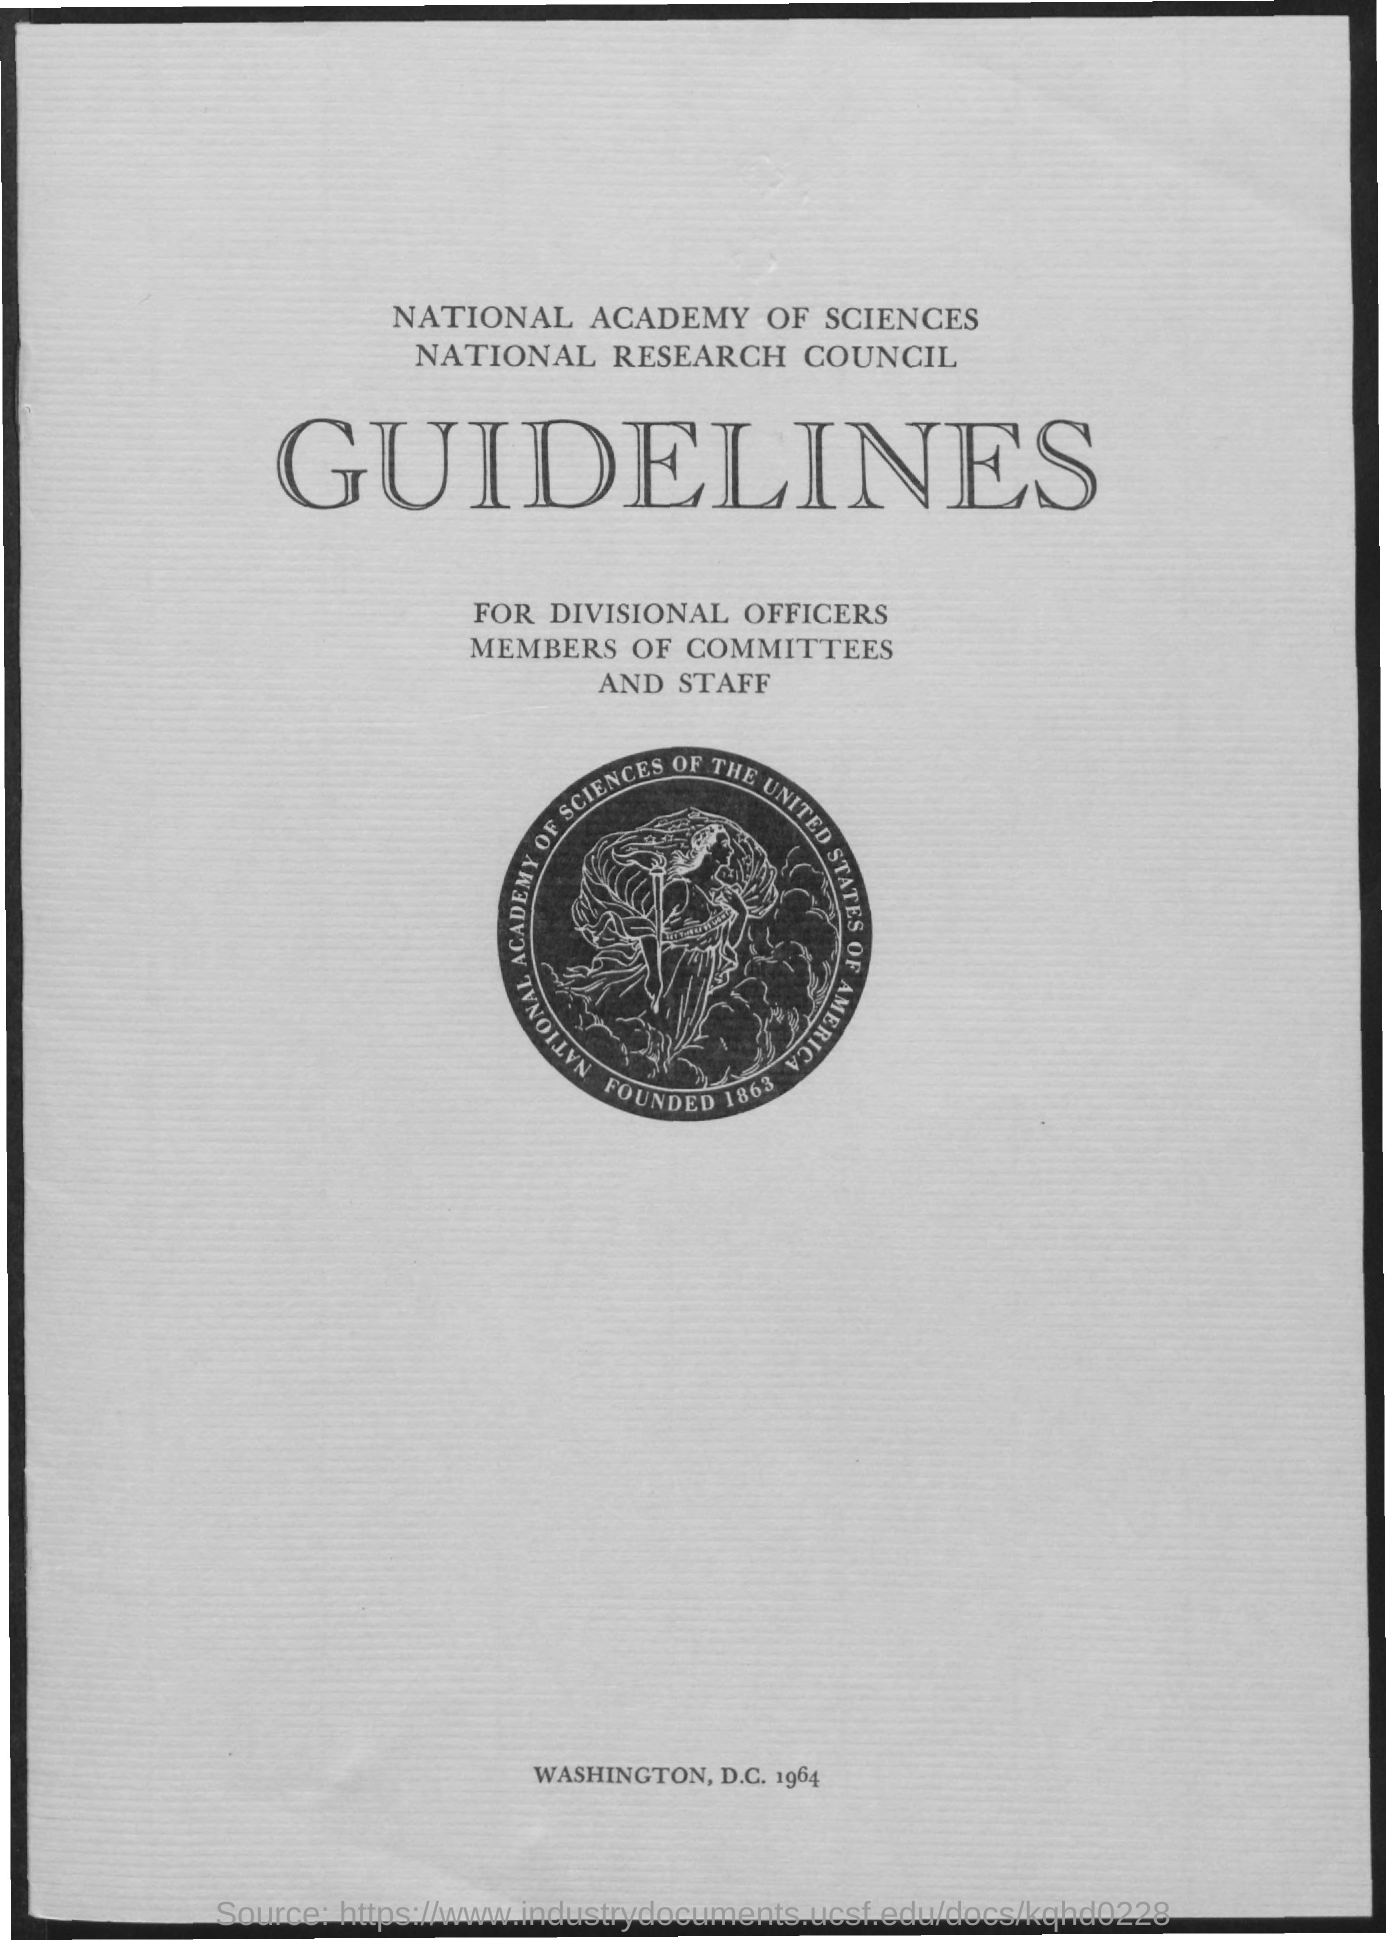Which year is at the bottom of the document?
Your answer should be very brief. 1964. Which year is in the image?
Offer a terse response. 1863. 